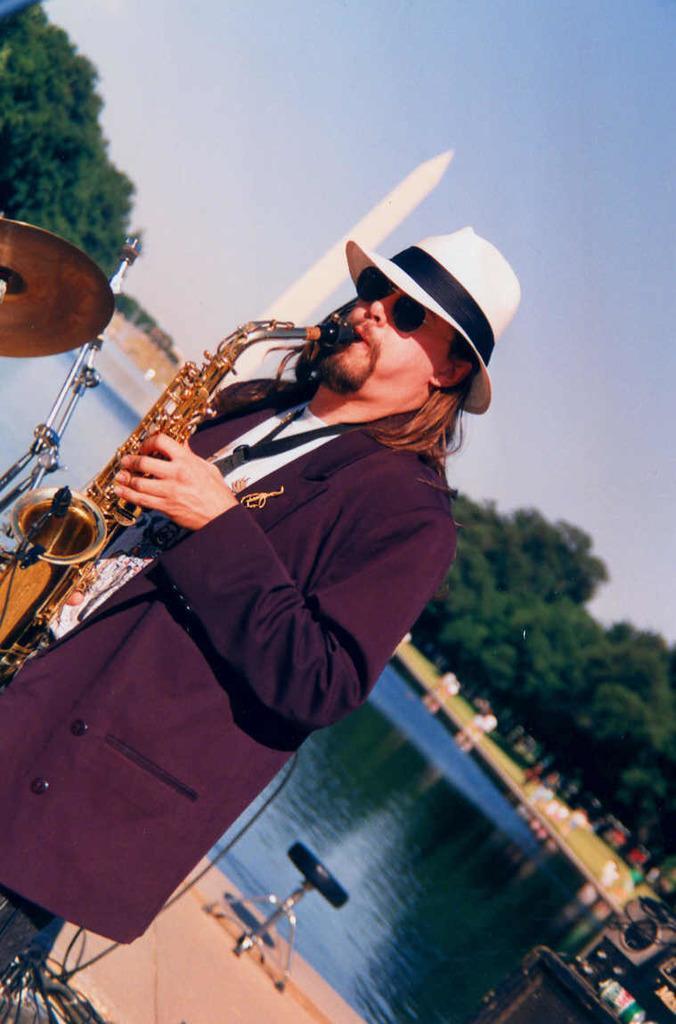Please provide a concise description of this image. In this image I can see one person is holding the musical instrument. I can see few trees, water, sky and few objects around. 